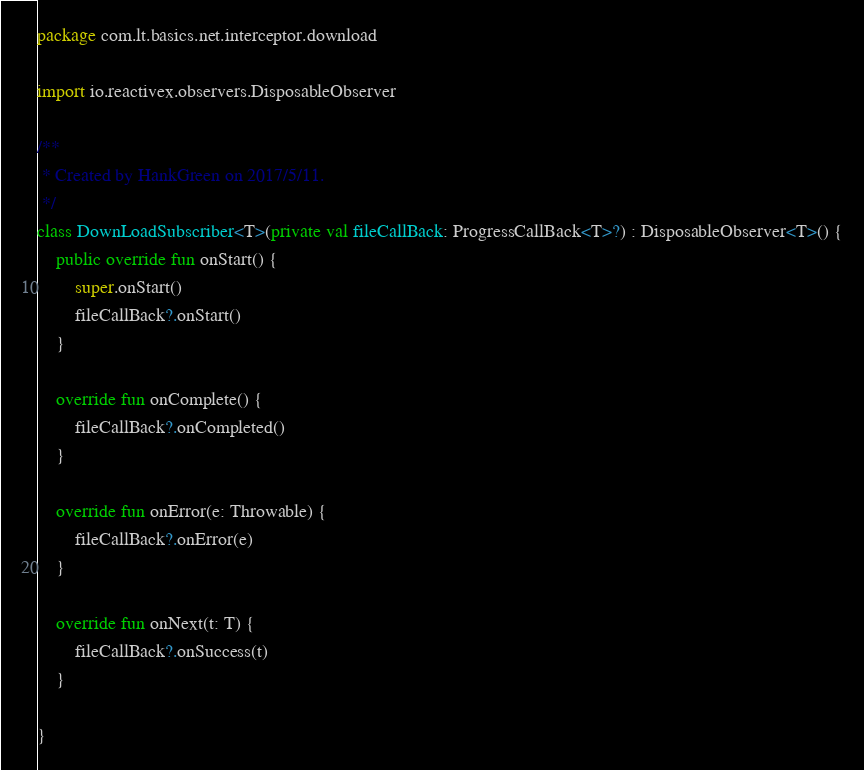Convert code to text. <code><loc_0><loc_0><loc_500><loc_500><_Kotlin_>package com.lt.basics.net.interceptor.download

import io.reactivex.observers.DisposableObserver

/**
 * Created by HankGreen on 2017/5/11.
 */
class DownLoadSubscriber<T>(private val fileCallBack: ProgressCallBack<T>?) : DisposableObserver<T>() {
    public override fun onStart() {
        super.onStart()
        fileCallBack?.onStart()
    }

    override fun onComplete() {
        fileCallBack?.onCompleted()
    }

    override fun onError(e: Throwable) {
        fileCallBack?.onError(e)
    }

    override fun onNext(t: T) {
        fileCallBack?.onSuccess(t)
    }

}</code> 